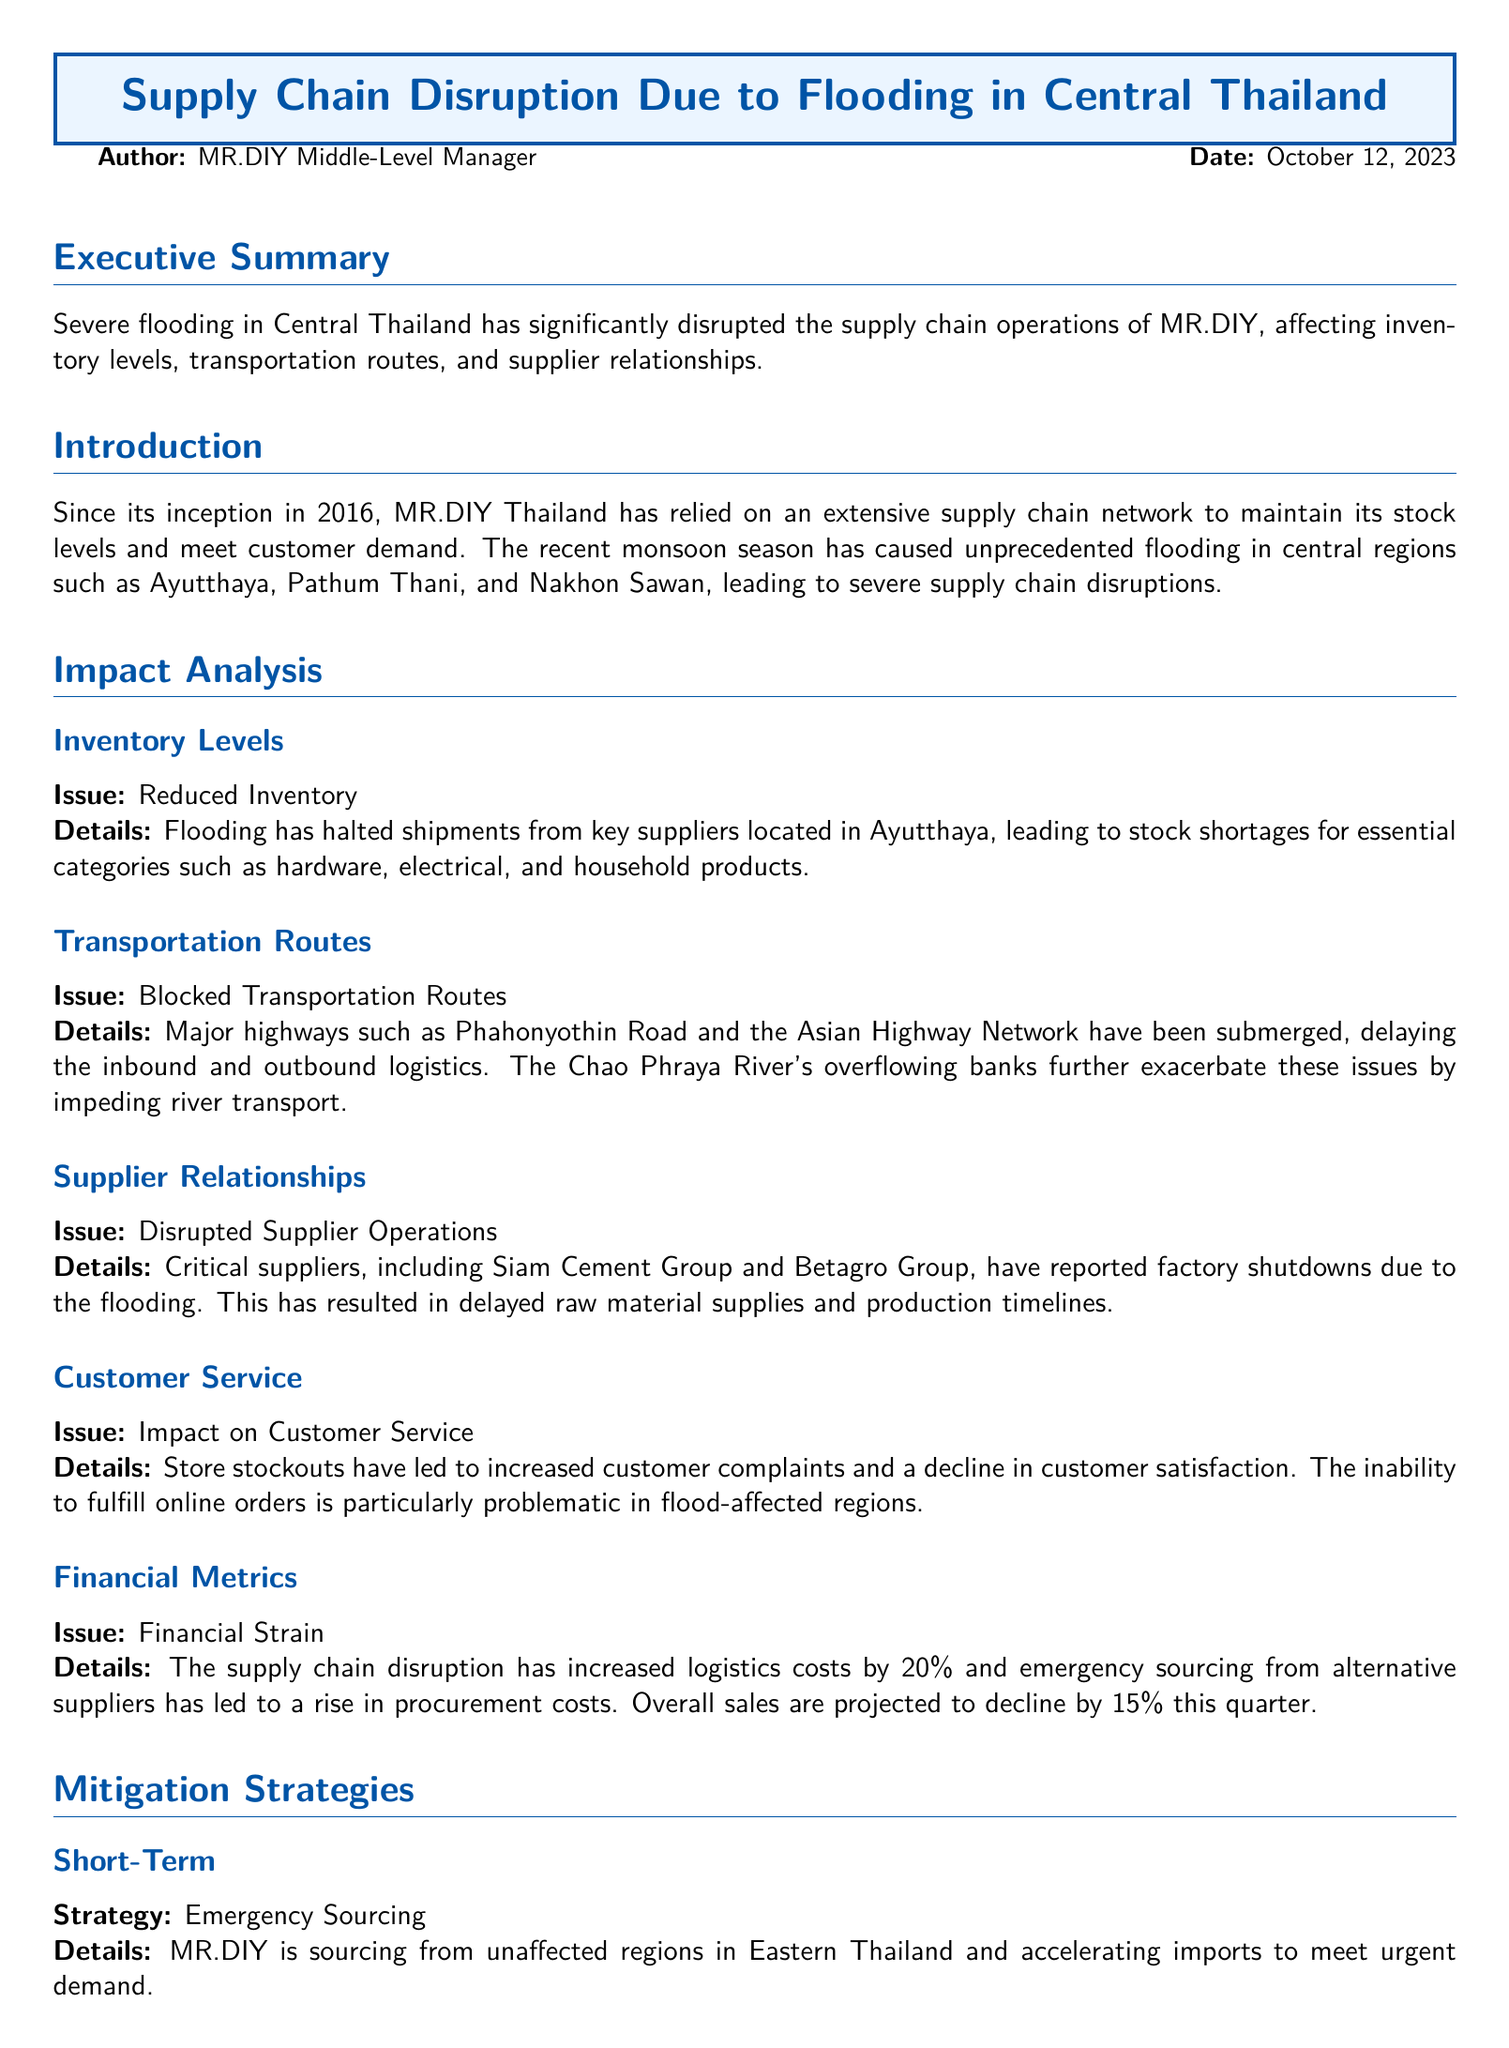what is the date of the report? The report is dated October 12, 2023.
Answer: October 12, 2023 who authored the report? The report was authored by the MR.DIY Middle-Level Manager.
Answer: MR.DIY Middle-Level Manager what are the affected regions mentioned? The report mentions Ayutthaya, Pathum Thani, and Nakhon Sawan as affected regions.
Answer: Ayutthaya, Pathum Thani, Nakhon Sawan what is the percentage increase in logistics costs? The document states that logistics costs have increased by 20%.
Answer: 20% how much are overall sales projected to decline? Projected decline in overall sales is reported at 15%.
Answer: 15% what short-term strategy is being implemented? The short-term strategy mentioned is emergency sourcing.
Answer: Emergency sourcing which major highways are mentioned as blocked? The major highways mentioned include Phahonyothin Road and the Asian Highway Network.
Answer: Phahonyothin Road, Asian Highway Network what is the long-term strategy for supply chain resilience? The long-term strategy involves diversifying the supplier base and investing in a regional distribution center.
Answer: Diversifying supplier base and investing in a regional distribution center which critical suppliers are reported to have shutdowns? The critical suppliers reported with shutdowns are Siam Cement Group and Betagro Group.
Answer: Siam Cement Group, Betagro Group 